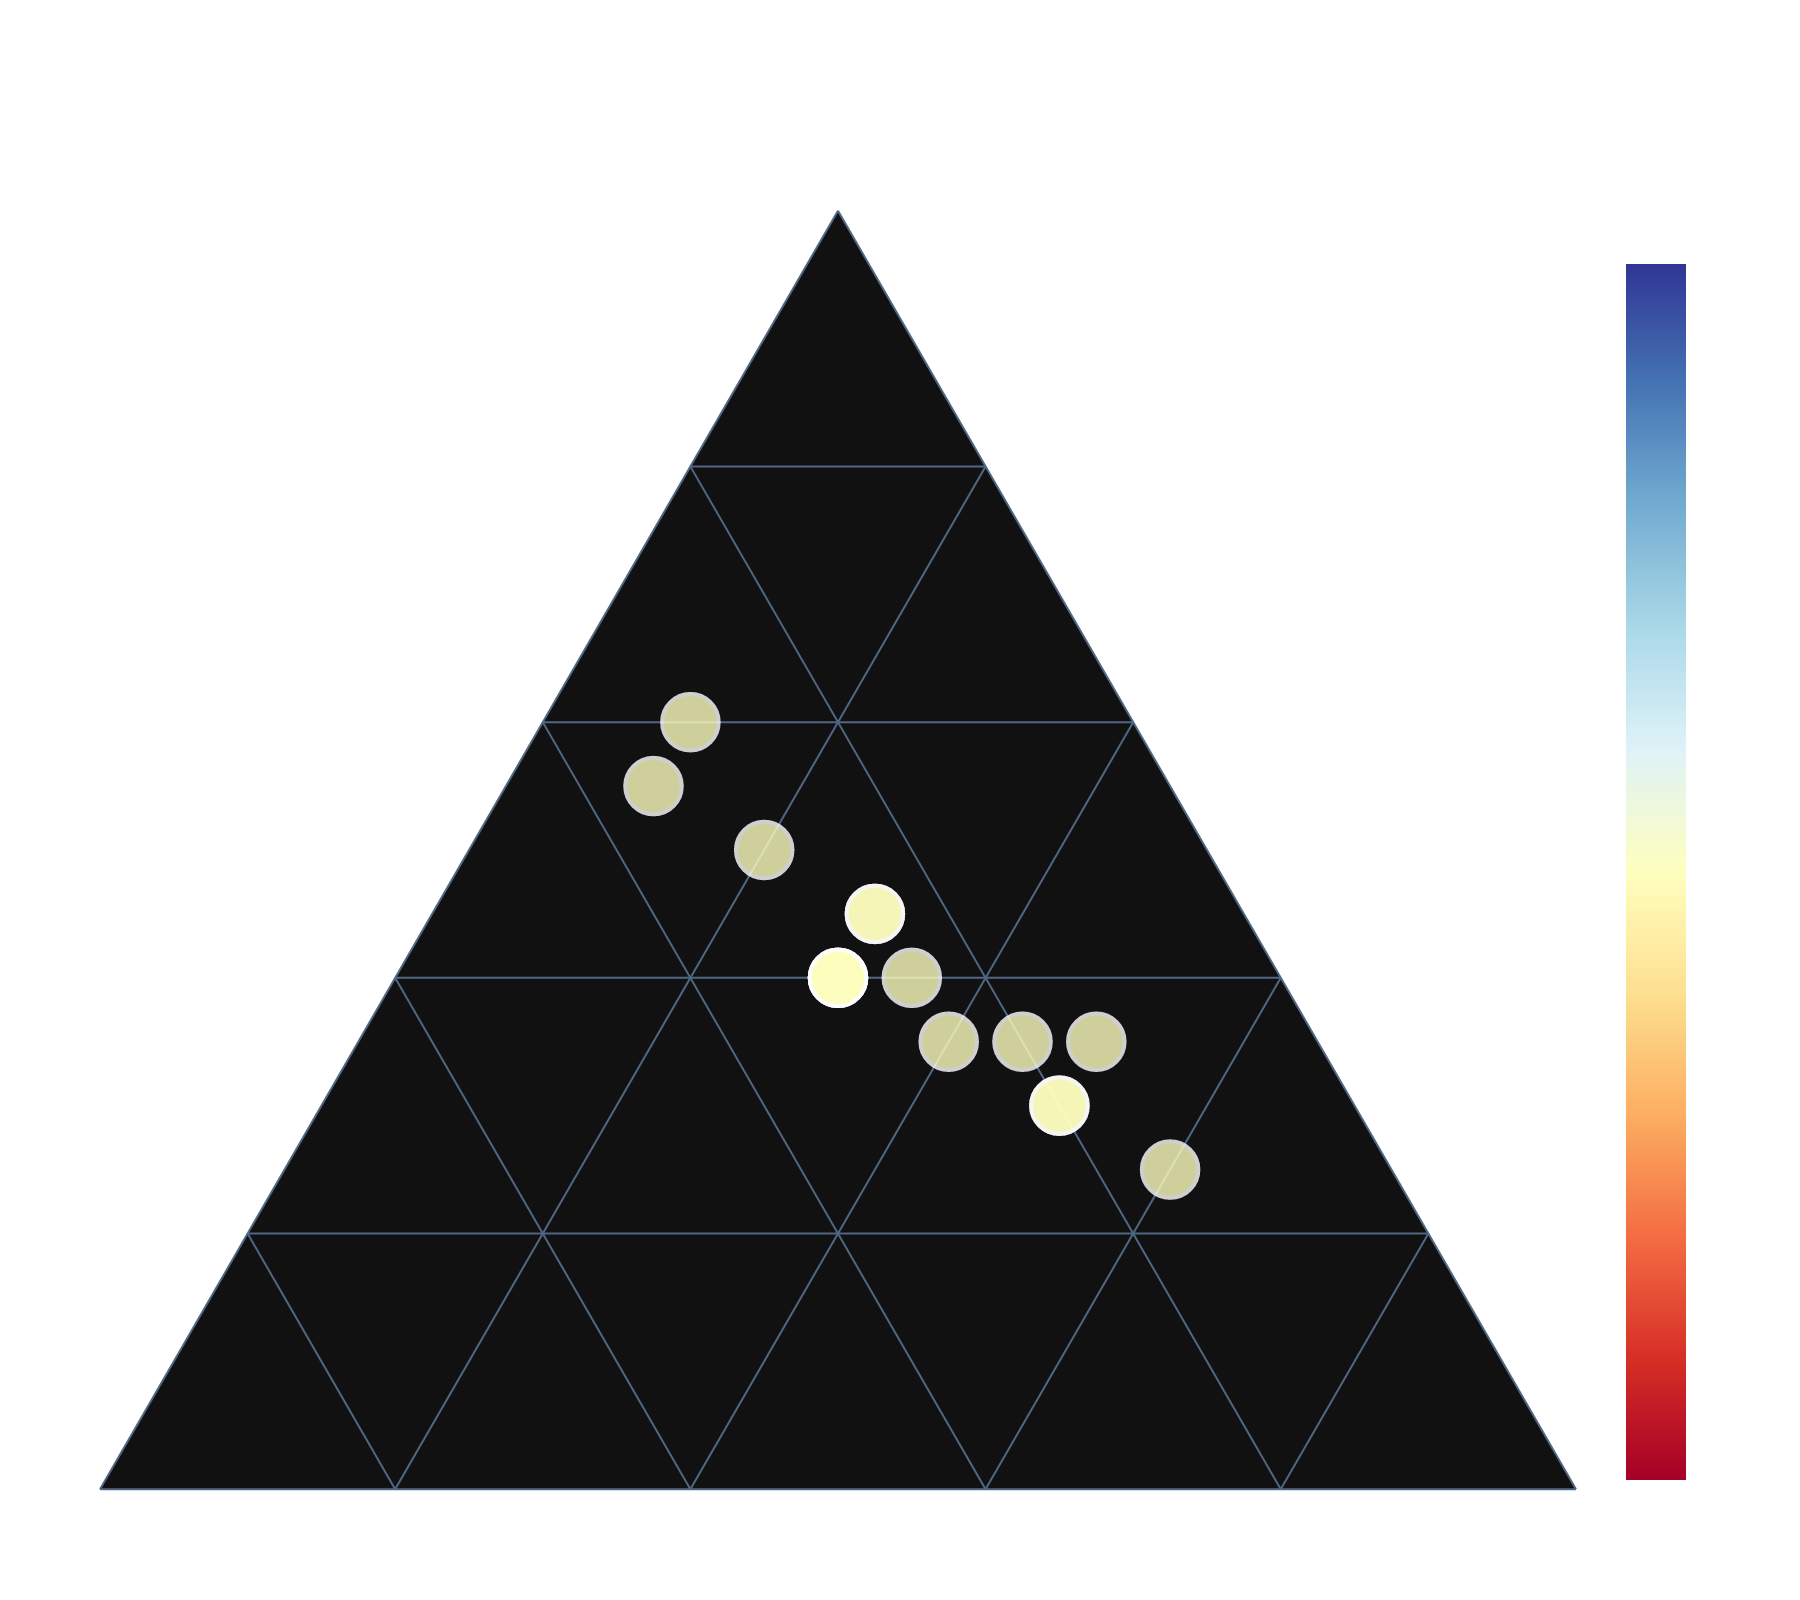What is the title of the ternary plot? The title is displayed at the top of the ternary plot in a large font with a white color.
Answer: Revenue Sources for College Sports Programs Which school relies the most on ticket sales for their revenue? Look for the point closest to the "Ticket Sales %" corner of the ternary plot. Wartburg College and Gonzaga University are the closest to this corner.
Answer: Wartburg College and Gonzaga University What percentage of University of Iowa's revenue comes from TV rights? Locate University of Iowa on the ternary plot and read its position relative to the "TV Rights %" axis.
Answer: 35% Which schools have an equal distribution of revenue among ticket sales, merchandise, and TV rights? Find points that are near the center of the ternary plot. This indicates an approximately equal percentage for all three sources.
Answer: Stanford University, University of North Carolina, Baylor University How does the revenue distribution of Duke University compare to that of University of Alabama? Check each school's position relative to the three axes: Ticket Sales %, Merchandise %, and TV Rights %. Duke University has a higher percentage from TV Rights and a lower percentage from ticket sales compared to University of Alabama.
Answer: Duke University relies more on TV rights while University of Alabama relies more on ticket sales Which school has the highest total revenue based on the size of the data points? Look for the largest data point on the plot, as the size represents total revenue.
Answer: The largest data point represents the school with the highest total revenue Between UCLA and University of Michigan, which one generates a higher percentage of revenue from merchandise? Locate both schools on the ternary plot and compare their positions relative to the "Merchandise %" axis. UCLA has a lower percentage from merchandise compared to University of Michigan.
Answer: University of Michigan What is the approximate percentage of merchandise revenue for Villanova University? Locate Villanova University on the ternary plot and read its position relative to the "Merchandise %" axis.
Answer: 30% 